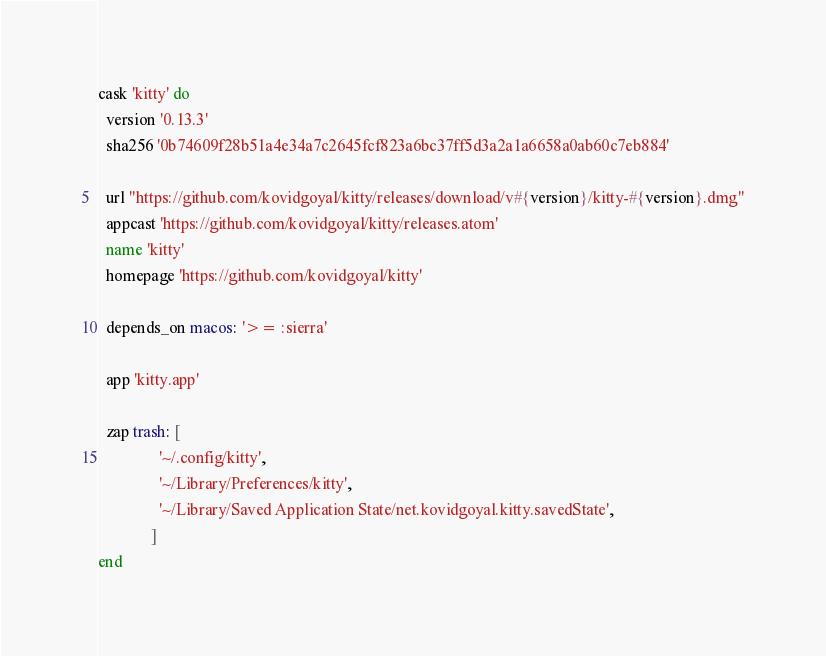Convert code to text. <code><loc_0><loc_0><loc_500><loc_500><_Ruby_>cask 'kitty' do
  version '0.13.3'
  sha256 '0b74609f28b51a4e34a7c2645fcf823a6bc37ff5d3a2a1a6658a0ab60c7eb884'

  url "https://github.com/kovidgoyal/kitty/releases/download/v#{version}/kitty-#{version}.dmg"
  appcast 'https://github.com/kovidgoyal/kitty/releases.atom'
  name 'kitty'
  homepage 'https://github.com/kovidgoyal/kitty'

  depends_on macos: '>= :sierra'

  app 'kitty.app'

  zap trash: [
               '~/.config/kitty',
               '~/Library/Preferences/kitty',
               '~/Library/Saved Application State/net.kovidgoyal.kitty.savedState',
             ]
end
</code> 